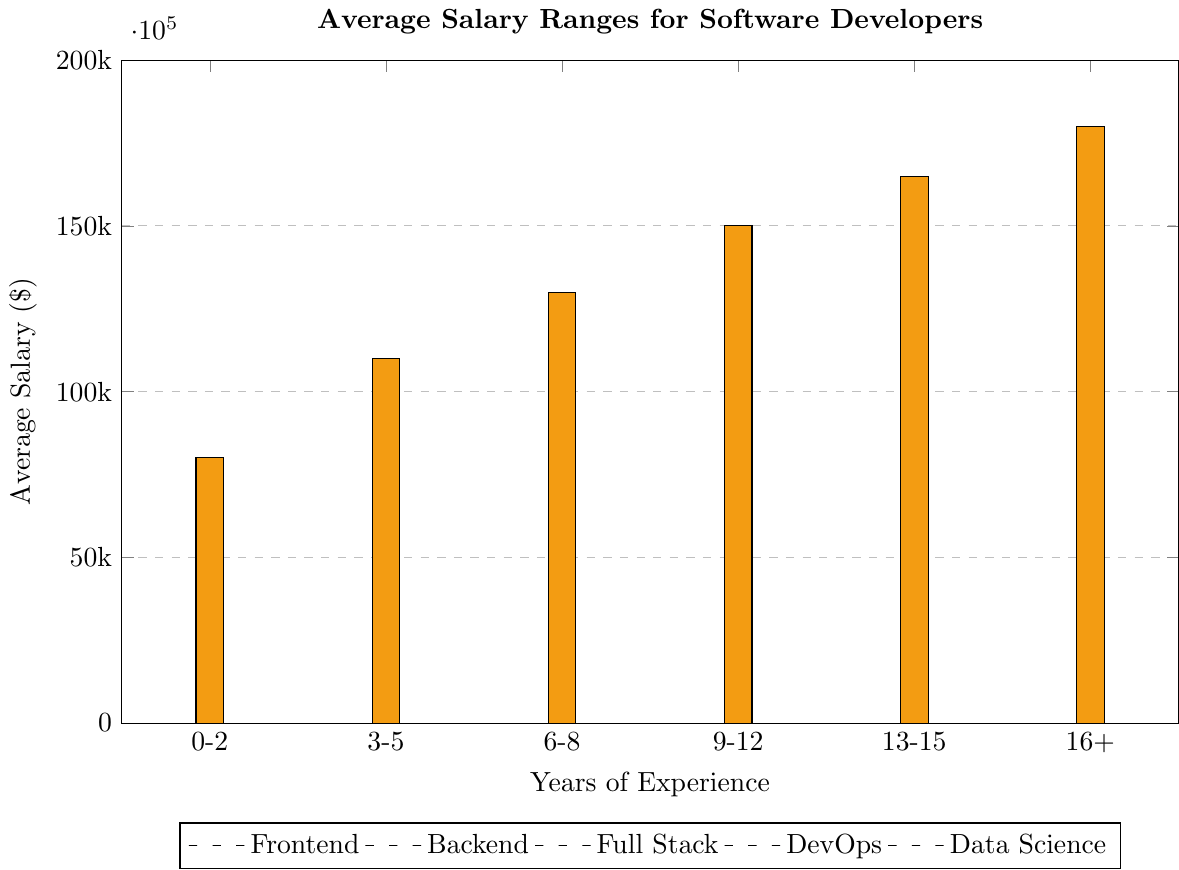what's the average salary for a Backend developer with 9-12 years of experience? The Backend salary for 9-12 years of experience is clearly indicated on the chart as the height of the red bar at that position, which is $130,000
Answer: $130,000 Which specialization has the highest average salary for individuals with 16+ years of experience? Looking at the bars for 16+ years of experience, the highest salary is observed with the tallest bar, which is yellow, representing Data Science, at $180,000
Answer: Data Science What's the difference in average salary between DevOps and Full Stack developers for the 3-5 years experience level? The DevOps salary at 3-5 years is marked with a purple bar at $100,000. The Full Stack salary is marked with a green bar at $95,000. The difference is $100,000 - $95,000 = $5,000
Answer: $5,000 What's the increase in average salary for a Frontend developer from 0-2 years to 6-8 years of experience? The Frontend salary for 0-2 years is $65,000, and for 6-8 years, it is $105,000. The increase is $105,000 - $65,000 = $40,000
Answer: $40,000 Compare the average salary of Backend developers with 6-8 years of experience to Data Science practitioners with 0-2 years of experience. Which group earns more and by how much? Backend developers with 6-8 years make $110,000; Data Science practitioners with 0-2 years make $80,000. Backend with 6-8 years earn more by $110,000 - $80,000 = $30,000
Answer: Backend developers with 6-8 years; $30,000 Which specialization shows the most significant salary increase from 0-2 years to 16+ years of experience? Calculating the difference for each specialization:
- Frontend: $155,000 - $65,000 = $90,000
- Backend: $160,000 - $70,000 = $90,000
- Full Stack: $165,000 - $72,000 = $93,000
- DevOps: $170,000 - $75,000 = $95,000
- Data Science: $180,000 - $80,000 = $100,000
The highest is Data Science with an increase of $100,000
Answer: Data Science; $100,000 If a Full Stack developer and a DevOps engineer both have 13-15 years of experience, what is the total of their average salaries? Full Stack salary for 13-15 years is $150,000. DevOps salary for 13-15 years is $155,000. The total is $150,000 + $155,000 = $305,000
Answer: $305,000 What is the median salary for Frontend developers across all experience levels? The salaries for Frontend developers are $65,000, $85,000, $105,000, $125,000, $140,000, and $155,000. Arranged in order, the median is the average of the 3rd and 4th values: ($105,000 + $125,000) / 2 = $115,000
Answer: $115,000 